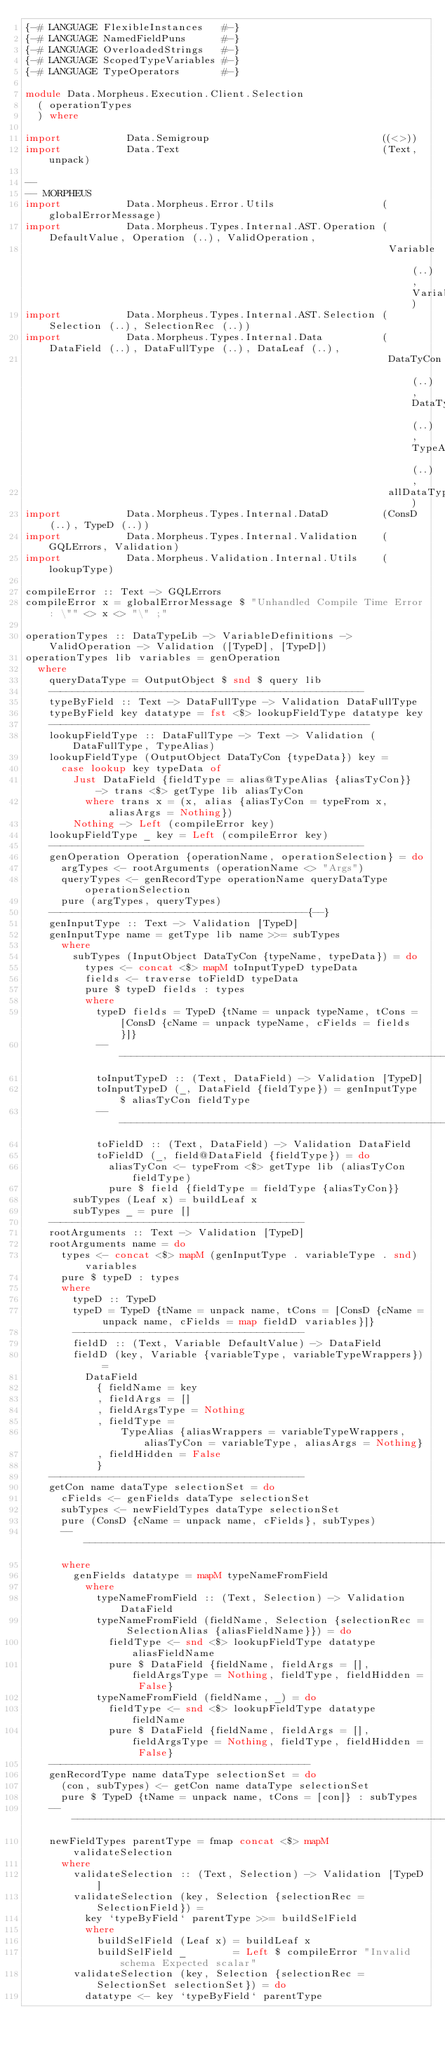<code> <loc_0><loc_0><loc_500><loc_500><_Haskell_>{-# LANGUAGE FlexibleInstances   #-}
{-# LANGUAGE NamedFieldPuns      #-}
{-# LANGUAGE OverloadedStrings   #-}
{-# LANGUAGE ScopedTypeVariables #-}
{-# LANGUAGE TypeOperators       #-}

module Data.Morpheus.Execution.Client.Selection
  ( operationTypes
  ) where

import           Data.Semigroup                             ((<>))
import           Data.Text                                  (Text, unpack)

--
-- MORPHEUS
import           Data.Morpheus.Error.Utils                  (globalErrorMessage)
import           Data.Morpheus.Types.Internal.AST.Operation (DefaultValue, Operation (..), ValidOperation,
                                                             Variable (..), VariableDefinitions)
import           Data.Morpheus.Types.Internal.AST.Selection (Selection (..), SelectionRec (..))
import           Data.Morpheus.Types.Internal.Data          (DataField (..), DataFullType (..), DataLeaf (..),
                                                             DataTyCon (..), DataTypeLib (..), TypeAlias (..),
                                                             allDataTypes)
import           Data.Morpheus.Types.Internal.DataD         (ConsD (..), TypeD (..))
import           Data.Morpheus.Types.Internal.Validation    (GQLErrors, Validation)
import           Data.Morpheus.Validation.Internal.Utils    (lookupType)

compileError :: Text -> GQLErrors
compileError x = globalErrorMessage $ "Unhandled Compile Time Error: \"" <> x <> "\" ;"

operationTypes :: DataTypeLib -> VariableDefinitions -> ValidOperation -> Validation ([TypeD], [TypeD])
operationTypes lib variables = genOperation
  where
    queryDataType = OutputObject $ snd $ query lib
    -----------------------------------------------------
    typeByField :: Text -> DataFullType -> Validation DataFullType
    typeByField key datatype = fst <$> lookupFieldType datatype key
    ------------------------------------------------------
    lookupFieldType :: DataFullType -> Text -> Validation (DataFullType, TypeAlias)
    lookupFieldType (OutputObject DataTyCon {typeData}) key =
      case lookup key typeData of
        Just DataField {fieldType = alias@TypeAlias {aliasTyCon}} -> trans <$> getType lib aliasTyCon
          where trans x = (x, alias {aliasTyCon = typeFrom x, aliasArgs = Nothing})
        Nothing -> Left (compileError key)
    lookupFieldType _ key = Left (compileError key)
    -----------------------------------------------------
    genOperation Operation {operationName, operationSelection} = do
      argTypes <- rootArguments (operationName <> "Args")
      queryTypes <- genRecordType operationName queryDataType operationSelection
      pure (argTypes, queryTypes)
    -------------------------------------------{--}
    genInputType :: Text -> Validation [TypeD]
    genInputType name = getType lib name >>= subTypes
      where
        subTypes (InputObject DataTyCon {typeName, typeData}) = do
          types <- concat <$> mapM toInputTypeD typeData
          fields <- traverse toFieldD typeData
          pure $ typeD fields : types
          where
            typeD fields = TypeD {tName = unpack typeName, tCons = [ConsD {cName = unpack typeName, cFields = fields}]}
            ---------------------------------------------------------------
            toInputTypeD :: (Text, DataField) -> Validation [TypeD]
            toInputTypeD (_, DataField {fieldType}) = genInputType $ aliasTyCon fieldType
            ----------------------------------------------------------------
            toFieldD :: (Text, DataField) -> Validation DataField
            toFieldD (_, field@DataField {fieldType}) = do
              aliasTyCon <- typeFrom <$> getType lib (aliasTyCon fieldType)
              pure $ field {fieldType = fieldType {aliasTyCon}}
        subTypes (Leaf x) = buildLeaf x
        subTypes _ = pure []
    -------------------------------------------
    rootArguments :: Text -> Validation [TypeD]
    rootArguments name = do
      types <- concat <$> mapM (genInputType . variableType . snd) variables
      pure $ typeD : types
      where
        typeD :: TypeD
        typeD = TypeD {tName = unpack name, tCons = [ConsD {cName = unpack name, cFields = map fieldD variables}]}
        ---------------------------------------
        fieldD :: (Text, Variable DefaultValue) -> DataField
        fieldD (key, Variable {variableType, variableTypeWrappers}) =
          DataField
            { fieldName = key
            , fieldArgs = []
            , fieldArgsType = Nothing
            , fieldType =
                TypeAlias {aliasWrappers = variableTypeWrappers, aliasTyCon = variableType, aliasArgs = Nothing}
            , fieldHidden = False
            }
    -------------------------------------------
    getCon name dataType selectionSet = do
      cFields <- genFields dataType selectionSet
      subTypes <- newFieldTypes dataType selectionSet
      pure (ConsD {cName = unpack name, cFields}, subTypes)
      ---------------------------------------------------------------------------------------------
      where
        genFields datatype = mapM typeNameFromField
          where
            typeNameFromField :: (Text, Selection) -> Validation DataField
            typeNameFromField (fieldName, Selection {selectionRec = SelectionAlias {aliasFieldName}}) = do
              fieldType <- snd <$> lookupFieldType datatype aliasFieldName
              pure $ DataField {fieldName, fieldArgs = [], fieldArgsType = Nothing, fieldType, fieldHidden = False}
            typeNameFromField (fieldName, _) = do
              fieldType <- snd <$> lookupFieldType datatype fieldName
              pure $ DataField {fieldName, fieldArgs = [], fieldArgsType = Nothing, fieldType, fieldHidden = False}
    --------------------------------------------
    genRecordType name dataType selectionSet = do
      (con, subTypes) <- getCon name dataType selectionSet
      pure $ TypeD {tName = unpack name, tCons = [con]} : subTypes
    ------------------------------------------------------------------------------------------------------------
    newFieldTypes parentType = fmap concat <$> mapM validateSelection
      where
        validateSelection :: (Text, Selection) -> Validation [TypeD]
        validateSelection (key, Selection {selectionRec = SelectionField}) =
          key `typeByField` parentType >>= buildSelField
          where
            buildSelField (Leaf x) = buildLeaf x
            buildSelField _        = Left $ compileError "Invalid schema Expected scalar"
        validateSelection (key, Selection {selectionRec = SelectionSet selectionSet}) = do
          datatype <- key `typeByField` parentType</code> 